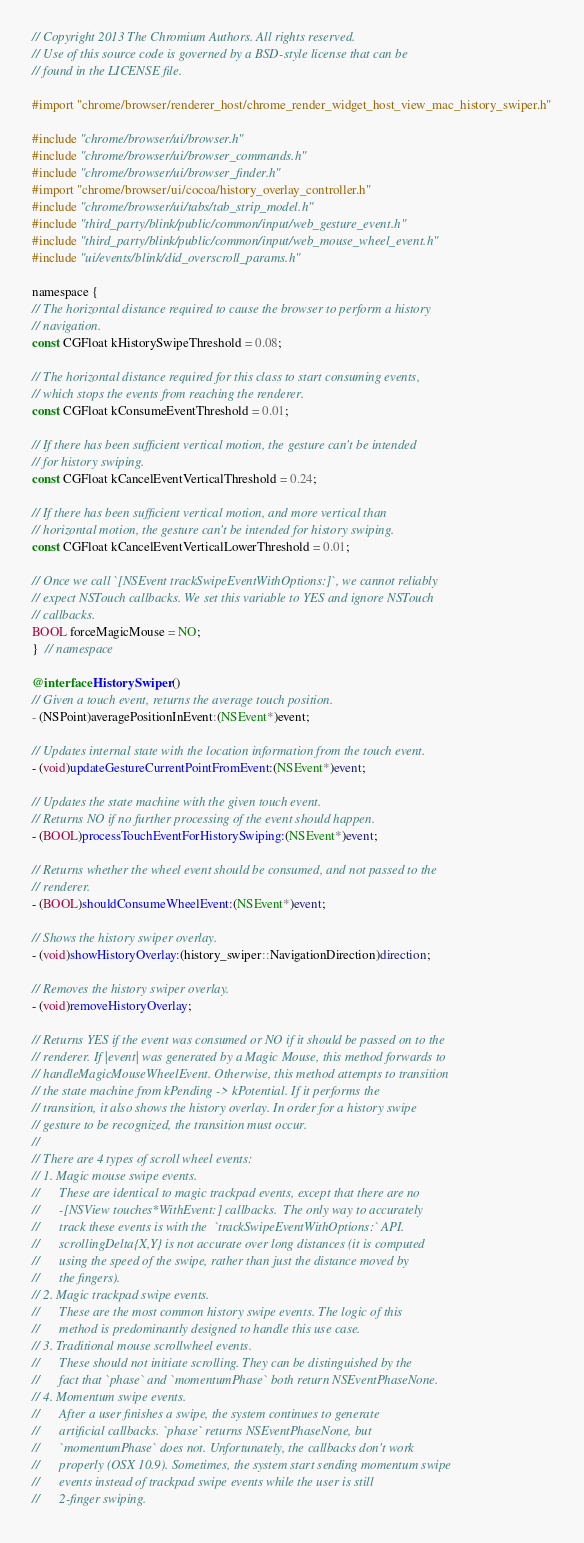<code> <loc_0><loc_0><loc_500><loc_500><_ObjectiveC_>// Copyright 2013 The Chromium Authors. All rights reserved.
// Use of this source code is governed by a BSD-style license that can be
// found in the LICENSE file.

#import "chrome/browser/renderer_host/chrome_render_widget_host_view_mac_history_swiper.h"

#include "chrome/browser/ui/browser.h"
#include "chrome/browser/ui/browser_commands.h"
#include "chrome/browser/ui/browser_finder.h"
#import "chrome/browser/ui/cocoa/history_overlay_controller.h"
#include "chrome/browser/ui/tabs/tab_strip_model.h"
#include "third_party/blink/public/common/input/web_gesture_event.h"
#include "third_party/blink/public/common/input/web_mouse_wheel_event.h"
#include "ui/events/blink/did_overscroll_params.h"

namespace {
// The horizontal distance required to cause the browser to perform a history
// navigation.
const CGFloat kHistorySwipeThreshold = 0.08;

// The horizontal distance required for this class to start consuming events,
// which stops the events from reaching the renderer.
const CGFloat kConsumeEventThreshold = 0.01;

// If there has been sufficient vertical motion, the gesture can't be intended
// for history swiping.
const CGFloat kCancelEventVerticalThreshold = 0.24;

// If there has been sufficient vertical motion, and more vertical than
// horizontal motion, the gesture can't be intended for history swiping.
const CGFloat kCancelEventVerticalLowerThreshold = 0.01;

// Once we call `[NSEvent trackSwipeEventWithOptions:]`, we cannot reliably
// expect NSTouch callbacks. We set this variable to YES and ignore NSTouch
// callbacks.
BOOL forceMagicMouse = NO;
}  // namespace

@interface HistorySwiper ()
// Given a touch event, returns the average touch position.
- (NSPoint)averagePositionInEvent:(NSEvent*)event;

// Updates internal state with the location information from the touch event.
- (void)updateGestureCurrentPointFromEvent:(NSEvent*)event;

// Updates the state machine with the given touch event.
// Returns NO if no further processing of the event should happen.
- (BOOL)processTouchEventForHistorySwiping:(NSEvent*)event;

// Returns whether the wheel event should be consumed, and not passed to the
// renderer.
- (BOOL)shouldConsumeWheelEvent:(NSEvent*)event;

// Shows the history swiper overlay.
- (void)showHistoryOverlay:(history_swiper::NavigationDirection)direction;

// Removes the history swiper overlay.
- (void)removeHistoryOverlay;

// Returns YES if the event was consumed or NO if it should be passed on to the
// renderer. If |event| was generated by a Magic Mouse, this method forwards to
// handleMagicMouseWheelEvent. Otherwise, this method attempts to transition
// the state machine from kPending -> kPotential. If it performs the
// transition, it also shows the history overlay. In order for a history swipe
// gesture to be recognized, the transition must occur.
//
// There are 4 types of scroll wheel events:
// 1. Magic mouse swipe events.
//      These are identical to magic trackpad events, except that there are no
//      -[NSView touches*WithEvent:] callbacks.  The only way to accurately
//      track these events is with the  `trackSwipeEventWithOptions:` API.
//      scrollingDelta{X,Y} is not accurate over long distances (it is computed
//      using the speed of the swipe, rather than just the distance moved by
//      the fingers).
// 2. Magic trackpad swipe events.
//      These are the most common history swipe events. The logic of this
//      method is predominantly designed to handle this use case.
// 3. Traditional mouse scrollwheel events.
//      These should not initiate scrolling. They can be distinguished by the
//      fact that `phase` and `momentumPhase` both return NSEventPhaseNone.
// 4. Momentum swipe events.
//      After a user finishes a swipe, the system continues to generate
//      artificial callbacks. `phase` returns NSEventPhaseNone, but
//      `momentumPhase` does not. Unfortunately, the callbacks don't work
//      properly (OSX 10.9). Sometimes, the system start sending momentum swipe
//      events instead of trackpad swipe events while the user is still
//      2-finger swiping.</code> 